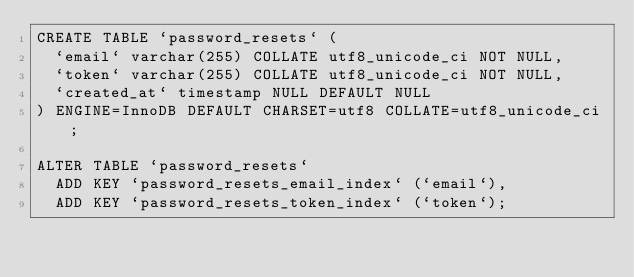<code> <loc_0><loc_0><loc_500><loc_500><_SQL_>CREATE TABLE `password_resets` (
  `email` varchar(255) COLLATE utf8_unicode_ci NOT NULL,
  `token` varchar(255) COLLATE utf8_unicode_ci NOT NULL,
  `created_at` timestamp NULL DEFAULT NULL
) ENGINE=InnoDB DEFAULT CHARSET=utf8 COLLATE=utf8_unicode_ci;

ALTER TABLE `password_resets` 
  ADD KEY `password_resets_email_index` (`email`),
  ADD KEY `password_resets_token_index` (`token`);</code> 